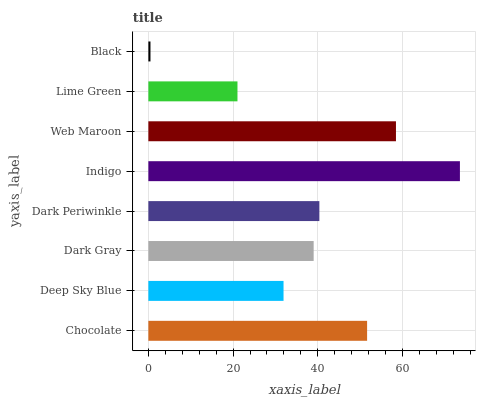Is Black the minimum?
Answer yes or no. Yes. Is Indigo the maximum?
Answer yes or no. Yes. Is Deep Sky Blue the minimum?
Answer yes or no. No. Is Deep Sky Blue the maximum?
Answer yes or no. No. Is Chocolate greater than Deep Sky Blue?
Answer yes or no. Yes. Is Deep Sky Blue less than Chocolate?
Answer yes or no. Yes. Is Deep Sky Blue greater than Chocolate?
Answer yes or no. No. Is Chocolate less than Deep Sky Blue?
Answer yes or no. No. Is Dark Periwinkle the high median?
Answer yes or no. Yes. Is Dark Gray the low median?
Answer yes or no. Yes. Is Lime Green the high median?
Answer yes or no. No. Is Deep Sky Blue the low median?
Answer yes or no. No. 